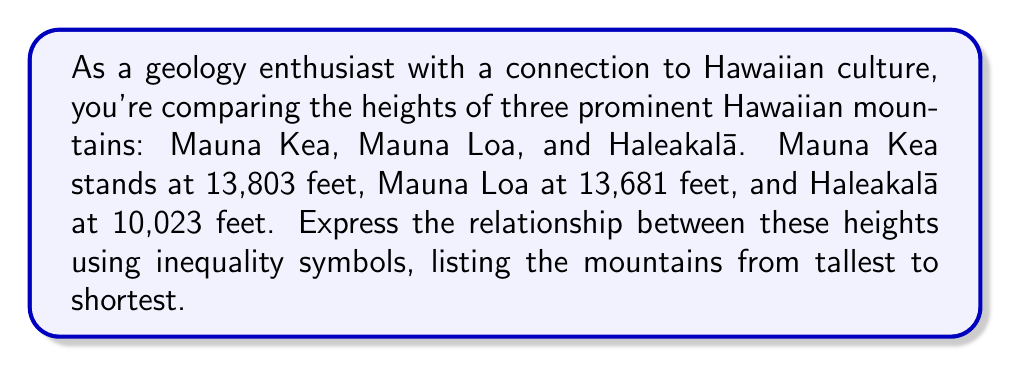Give your solution to this math problem. To solve this problem, we need to compare the given heights and arrange them in descending order:

1. Mauna Kea: 13,803 feet
2. Mauna Loa: 13,681 feet
3. Haleakalā: 10,023 feet

Comparing these heights:

13,803 > 13,681 > 10,023

Now, let's assign variables to represent each mountain:

Let $M_K$ = height of Mauna Kea
Let $M_L$ = height of Mauna Loa
Let $H$ = height of Haleakalā

We can now express the relationship using inequality symbols:

$M_K > M_L > H$

This inequality shows that Mauna Kea is taller than Mauna Loa, which is taller than Haleakalā.
Answer: $M_K > M_L > H$ 